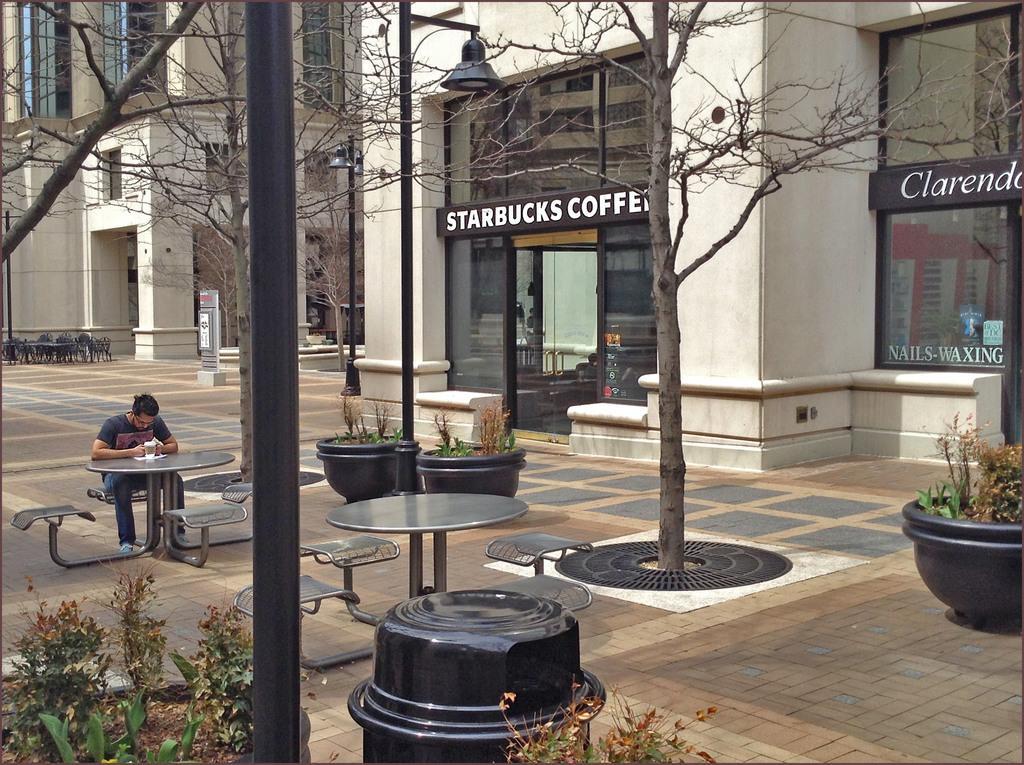In one or two sentences, can you explain what this image depicts? In this picture there are tables and chairs around the area of the image, it seems to be area where, there is a coffee shop at the right side of the image and there are some trees around the area of the image. 